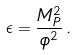Convert formula to latex. <formula><loc_0><loc_0><loc_500><loc_500>\epsilon = \frac { M _ { P } ^ { 2 } } { \phi ^ { 2 } } \, .</formula> 